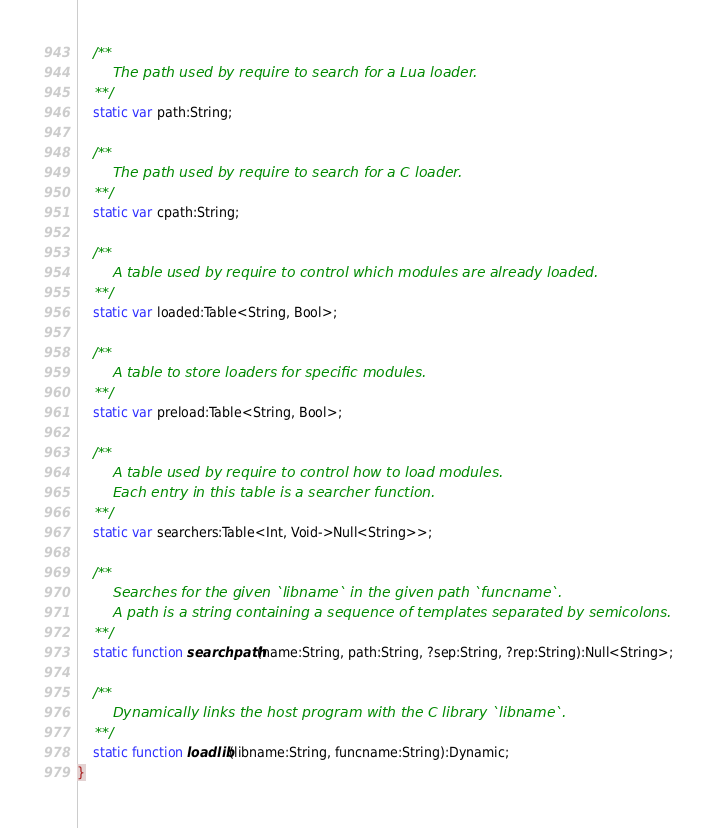Convert code to text. <code><loc_0><loc_0><loc_500><loc_500><_Haxe_>	/**
		The path used by require to search for a Lua loader.
	**/
	static var path:String;

	/**
		The path used by require to search for a C loader.
	**/
	static var cpath:String;

	/**
		A table used by require to control which modules are already loaded.
	**/
	static var loaded:Table<String, Bool>;

	/**
		A table to store loaders for specific modules.
	**/
	static var preload:Table<String, Bool>;

	/**
		A table used by require to control how to load modules.
		Each entry in this table is a searcher function.
	**/
	static var searchers:Table<Int, Void->Null<String>>;

	/**
		Searches for the given `libname` in the given path `funcname`.
		A path is a string containing a sequence of templates separated by semicolons.
	**/
	static function searchpath(name:String, path:String, ?sep:String, ?rep:String):Null<String>;

	/**
		Dynamically links the host program with the C library `libname`.
	**/
	static function loadlib(libname:String, funcname:String):Dynamic;
}
</code> 